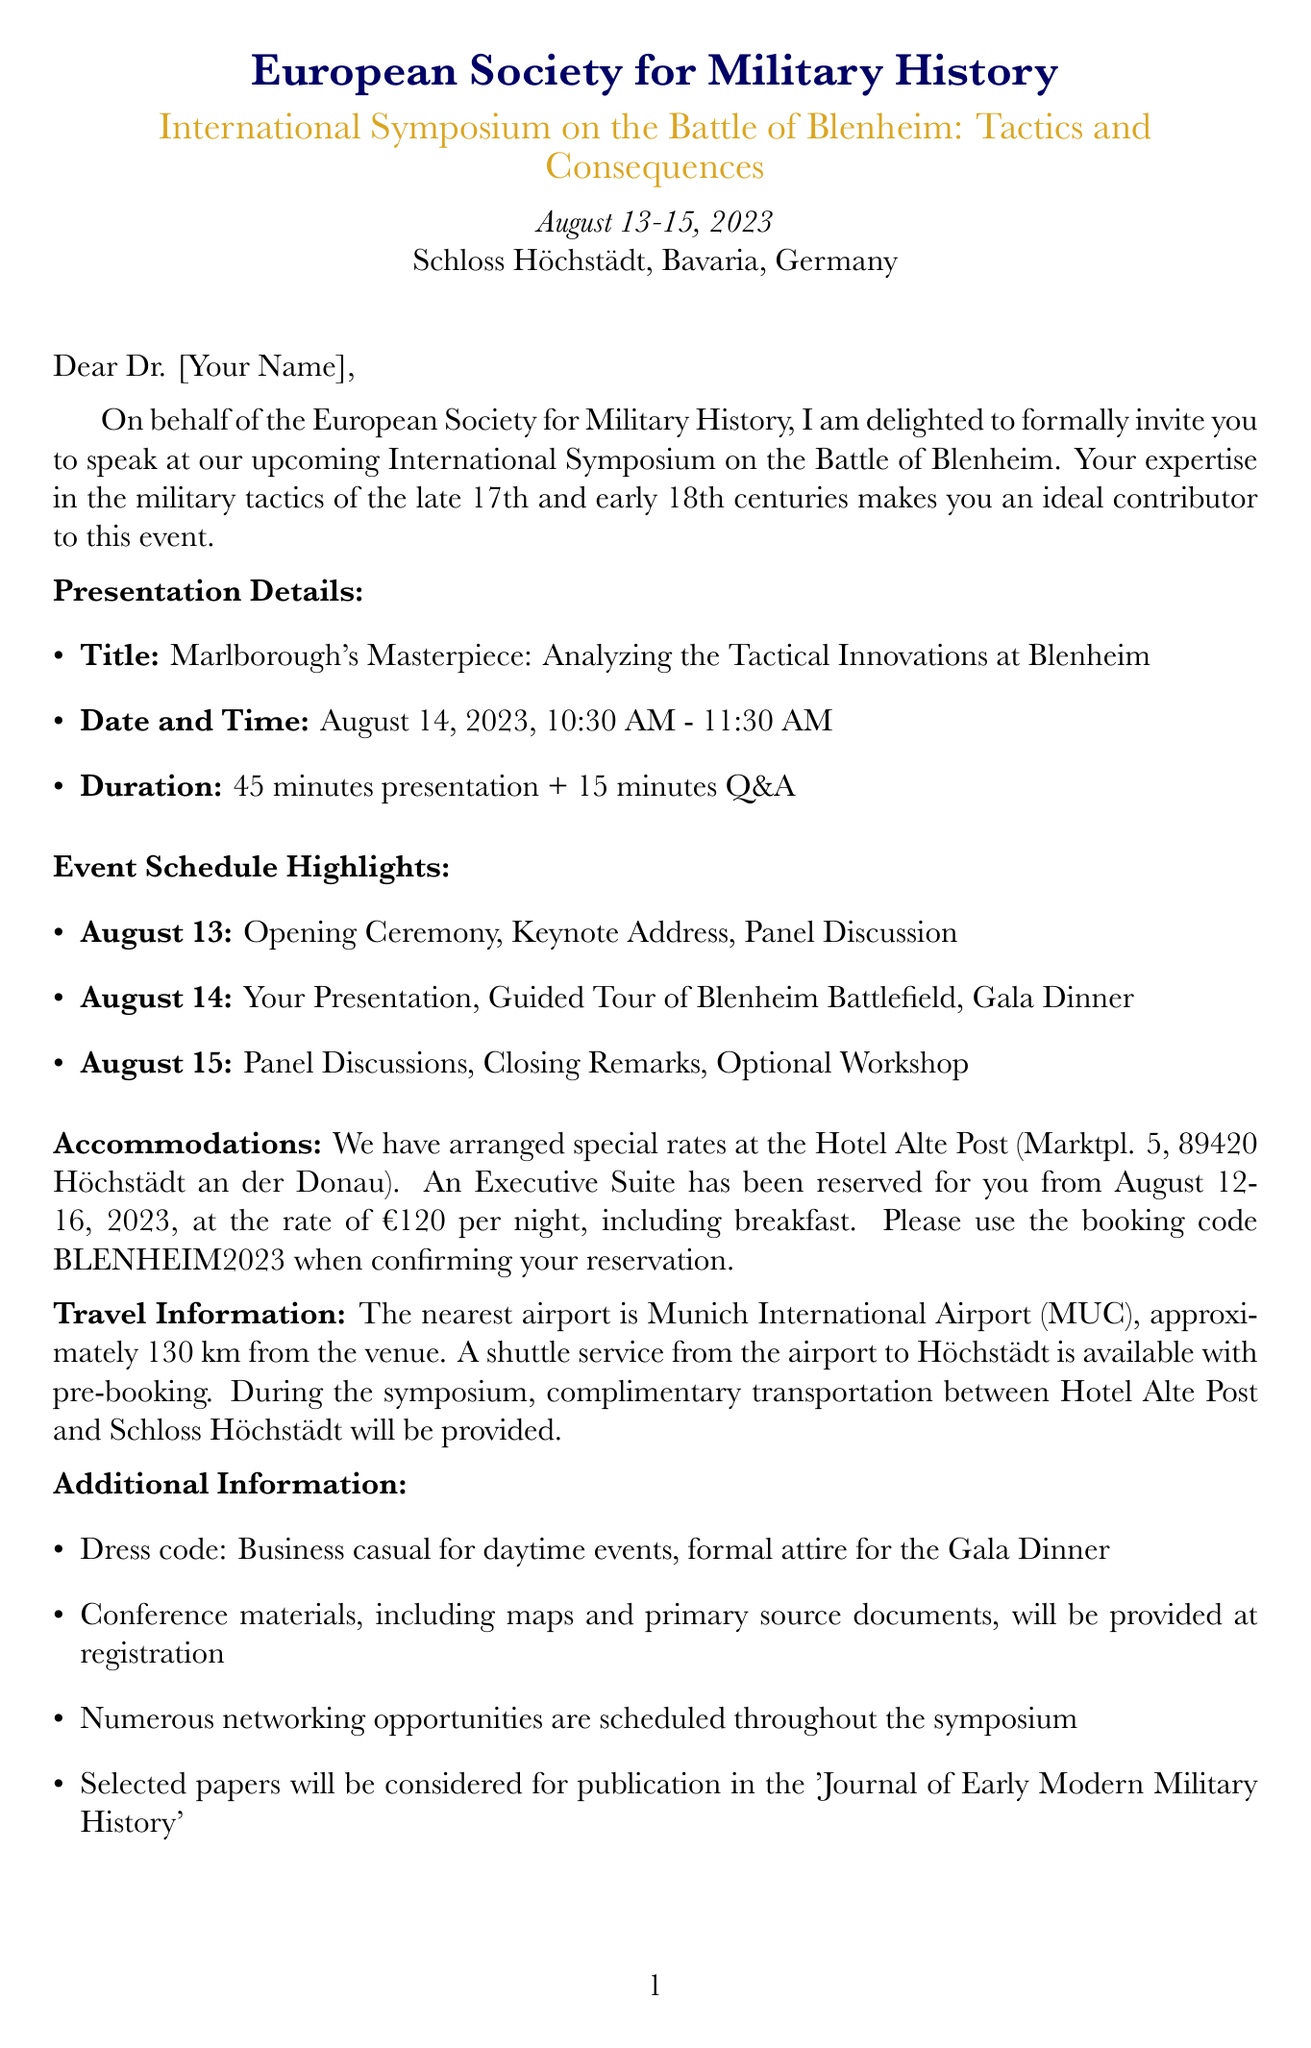What is the event name? The event name is stated clearly in the document, and it is the title of the symposium.
Answer: International Symposium on the Battle of Blenheim: Tactics and Consequences Who is the organizer? The document specifies the organization responsible for hosting the event.
Answer: European Society for Military History What are the presentation details? The presentation details, including title, date, and time, are explicitly mentioned in the document.
Answer: Marlborough's Masterpiece: Analyzing the Tactical Innovations at Blenheim What is the duration of the presentation? The document clearly states how long the presentation will last, including the Q&A.
Answer: 45 minutes + 15 minutes Q&A When is the Gala Dinner scheduled? The date and time for the Gala Dinner can be found in the event schedule section of the document.
Answer: August 14, 2023, 7:00 PM What type of accommodations are recommended? The recommended hotel and room type are specified in the accommodations section of the letter.
Answer: Executive Suite What is the special rate per night at the recommended hotel? The document mentions the cost for staying in the recommended hotel, which includes breakfast.
Answer: €120 per night What is the dress code for daytime events? The document outlines the required dress code for different times of the day regarding the event.
Answer: Business casual Where is the nearest airport? The document provides specific travel information, including the closest airport to the venue.
Answer: Munich International Airport (MUC) 